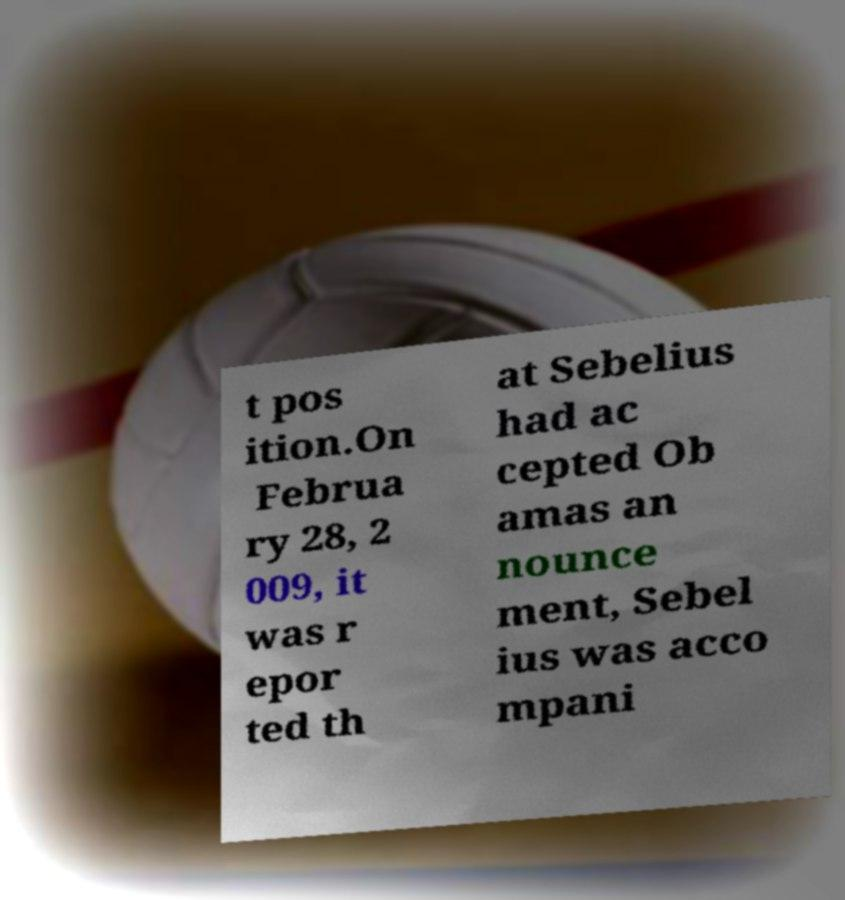Can you accurately transcribe the text from the provided image for me? t pos ition.On Februa ry 28, 2 009, it was r epor ted th at Sebelius had ac cepted Ob amas an nounce ment, Sebel ius was acco mpani 